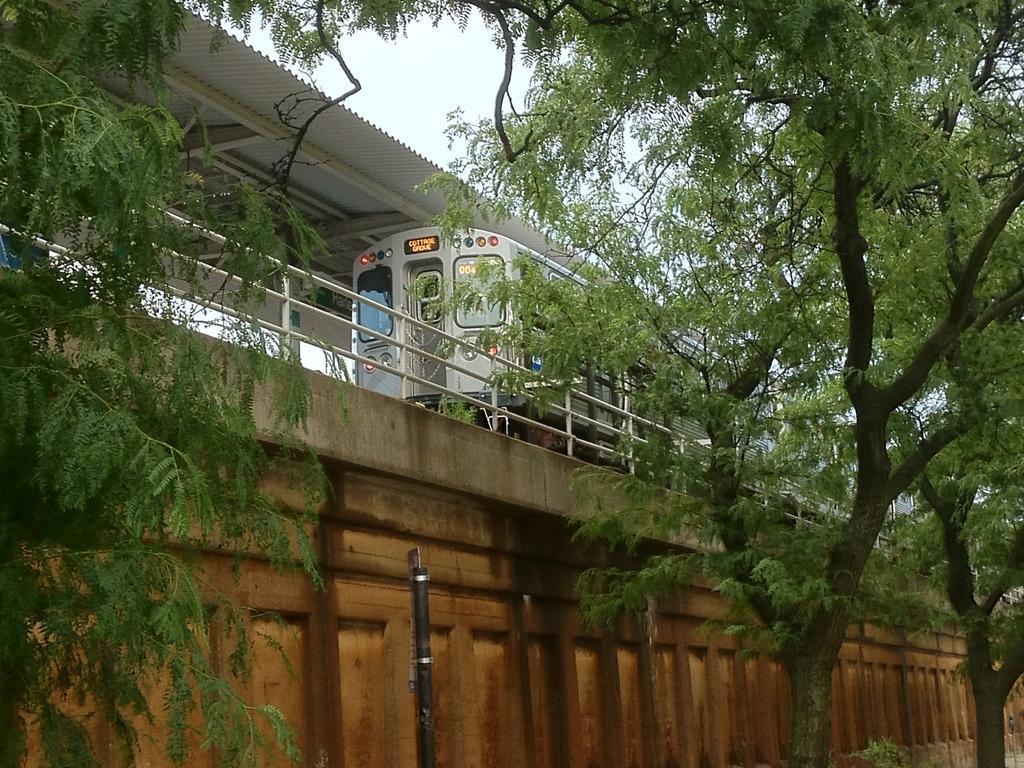How would you summarize this image in a sentence or two? In this image we can see there is a train on the track, above the train there is a metal shed. In front of the train there is a railing. On the right and left side of the image there are trees. 